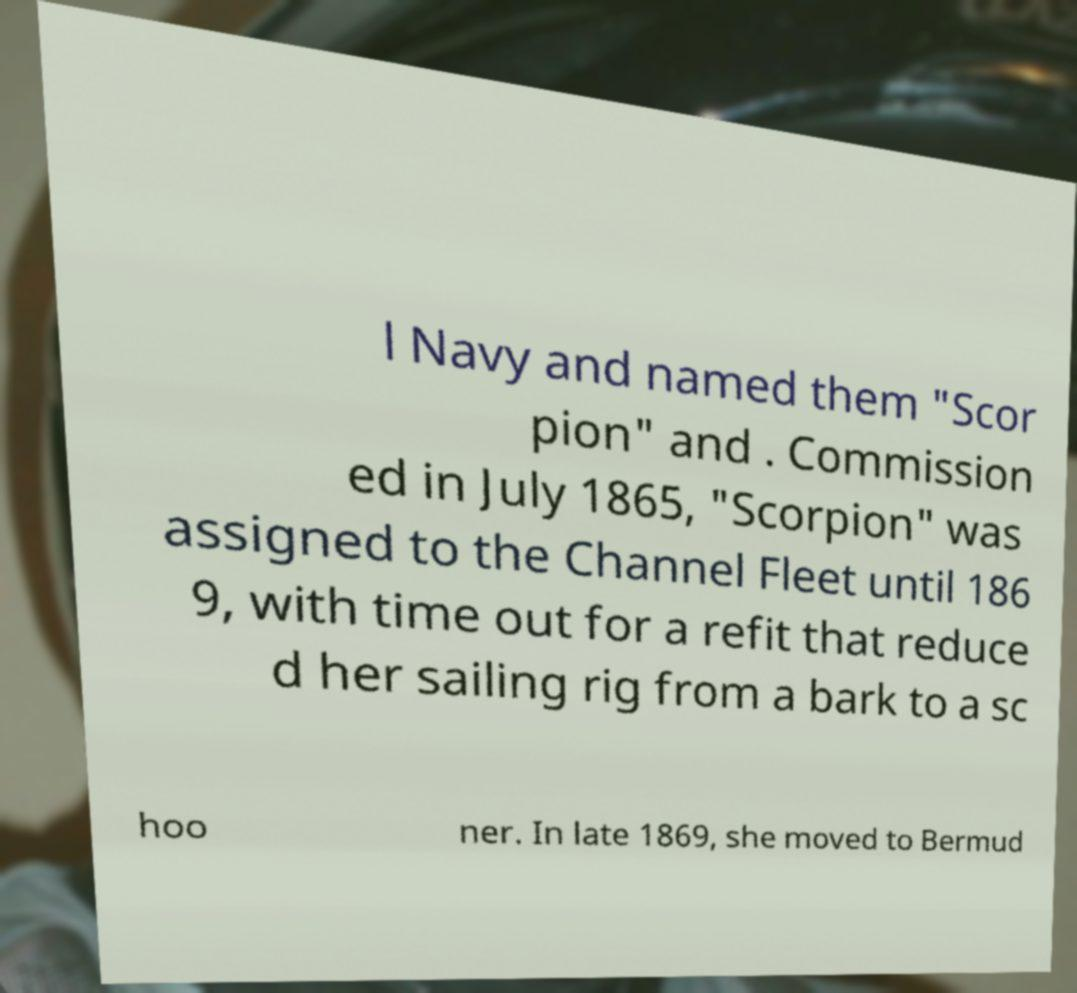Can you read and provide the text displayed in the image?This photo seems to have some interesting text. Can you extract and type it out for me? l Navy and named them "Scor pion" and . Commission ed in July 1865, "Scorpion" was assigned to the Channel Fleet until 186 9, with time out for a refit that reduce d her sailing rig from a bark to a sc hoo ner. In late 1869, she moved to Bermud 